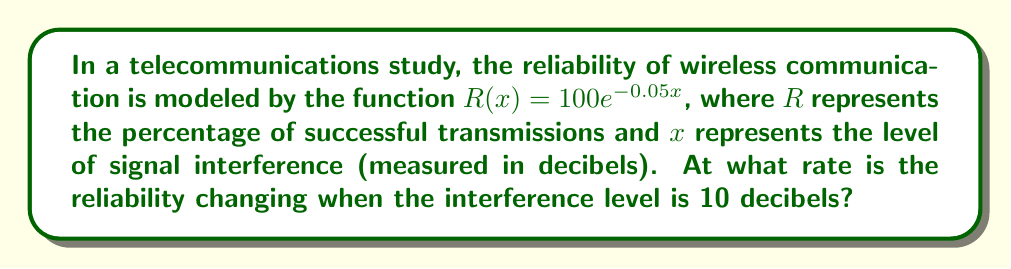What is the answer to this math problem? To find the rate at which reliability is changing with respect to interference, we need to find the derivative of $R(x)$ and evaluate it at $x = 10$.

1) The given function is $R(x) = 100e^{-0.05x}$

2) To find the derivative, we use the chain rule:
   $$\frac{dR}{dx} = 100 \cdot \frac{d}{dx}(e^{-0.05x})$$
   $$= 100 \cdot e^{-0.05x} \cdot (-0.05)$$
   $$= -5e^{-0.05x}$$

3) Now we evaluate this derivative at $x = 10$:
   $$\frac{dR}{dx}(10) = -5e^{-0.05(10)}$$
   $$= -5e^{-0.5}$$
   $$\approx -3.0327$$

4) This means that when the interference level is 10 decibels, the reliability is decreasing at a rate of approximately 3.0327 percentage points per unit increase in interference.
Answer: $-5e^{-0.5}$ percentage points per decibel 